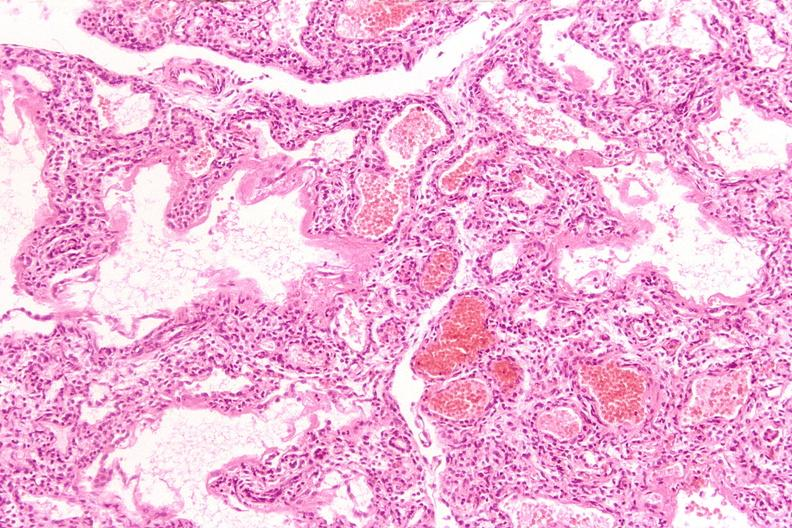s simian crease present?
Answer the question using a single word or phrase. No 